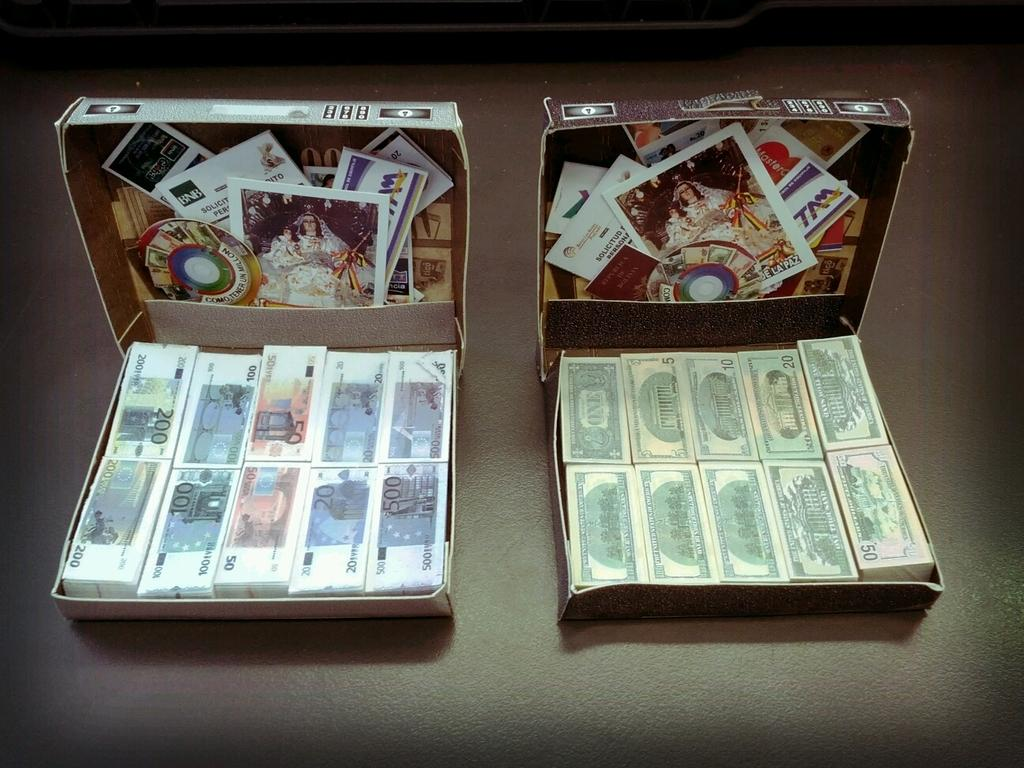<image>
Offer a succinct explanation of the picture presented. open cartons of money with a paper that says 'bnb' on the top left corner 